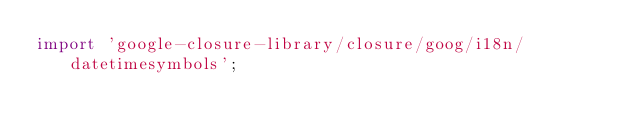<code> <loc_0><loc_0><loc_500><loc_500><_TypeScript_>import 'google-closure-library/closure/goog/i18n/datetimesymbols';
</code> 